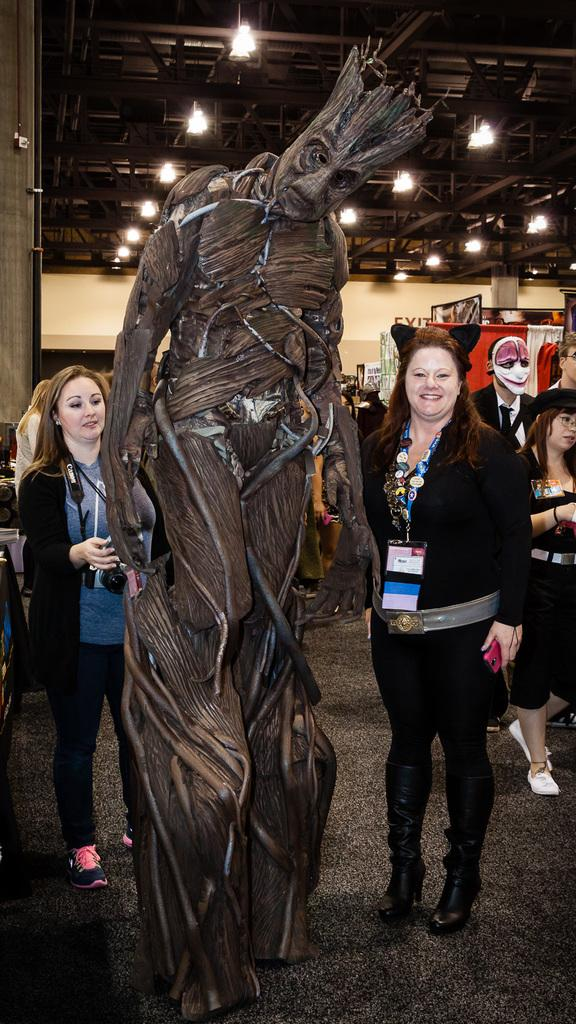What is the main subject in the image? There is a statue in the image. What are the people near the statue doing? People are standing near the statue. Can you describe the lady on the left side of the image? The lady on the left side of the image is wearing a camera. What is the other lady holding and wearing? Another lady is wearing a tag and holding a mobile. What can be seen on the ceiling in the image? There are lights on the ceiling in the image. What type of weather can be seen in the image? There is no indication of weather in the image, as it is focused on the statue and the people around it. Are there any toys visible in the image? There are no toys present in the image. 